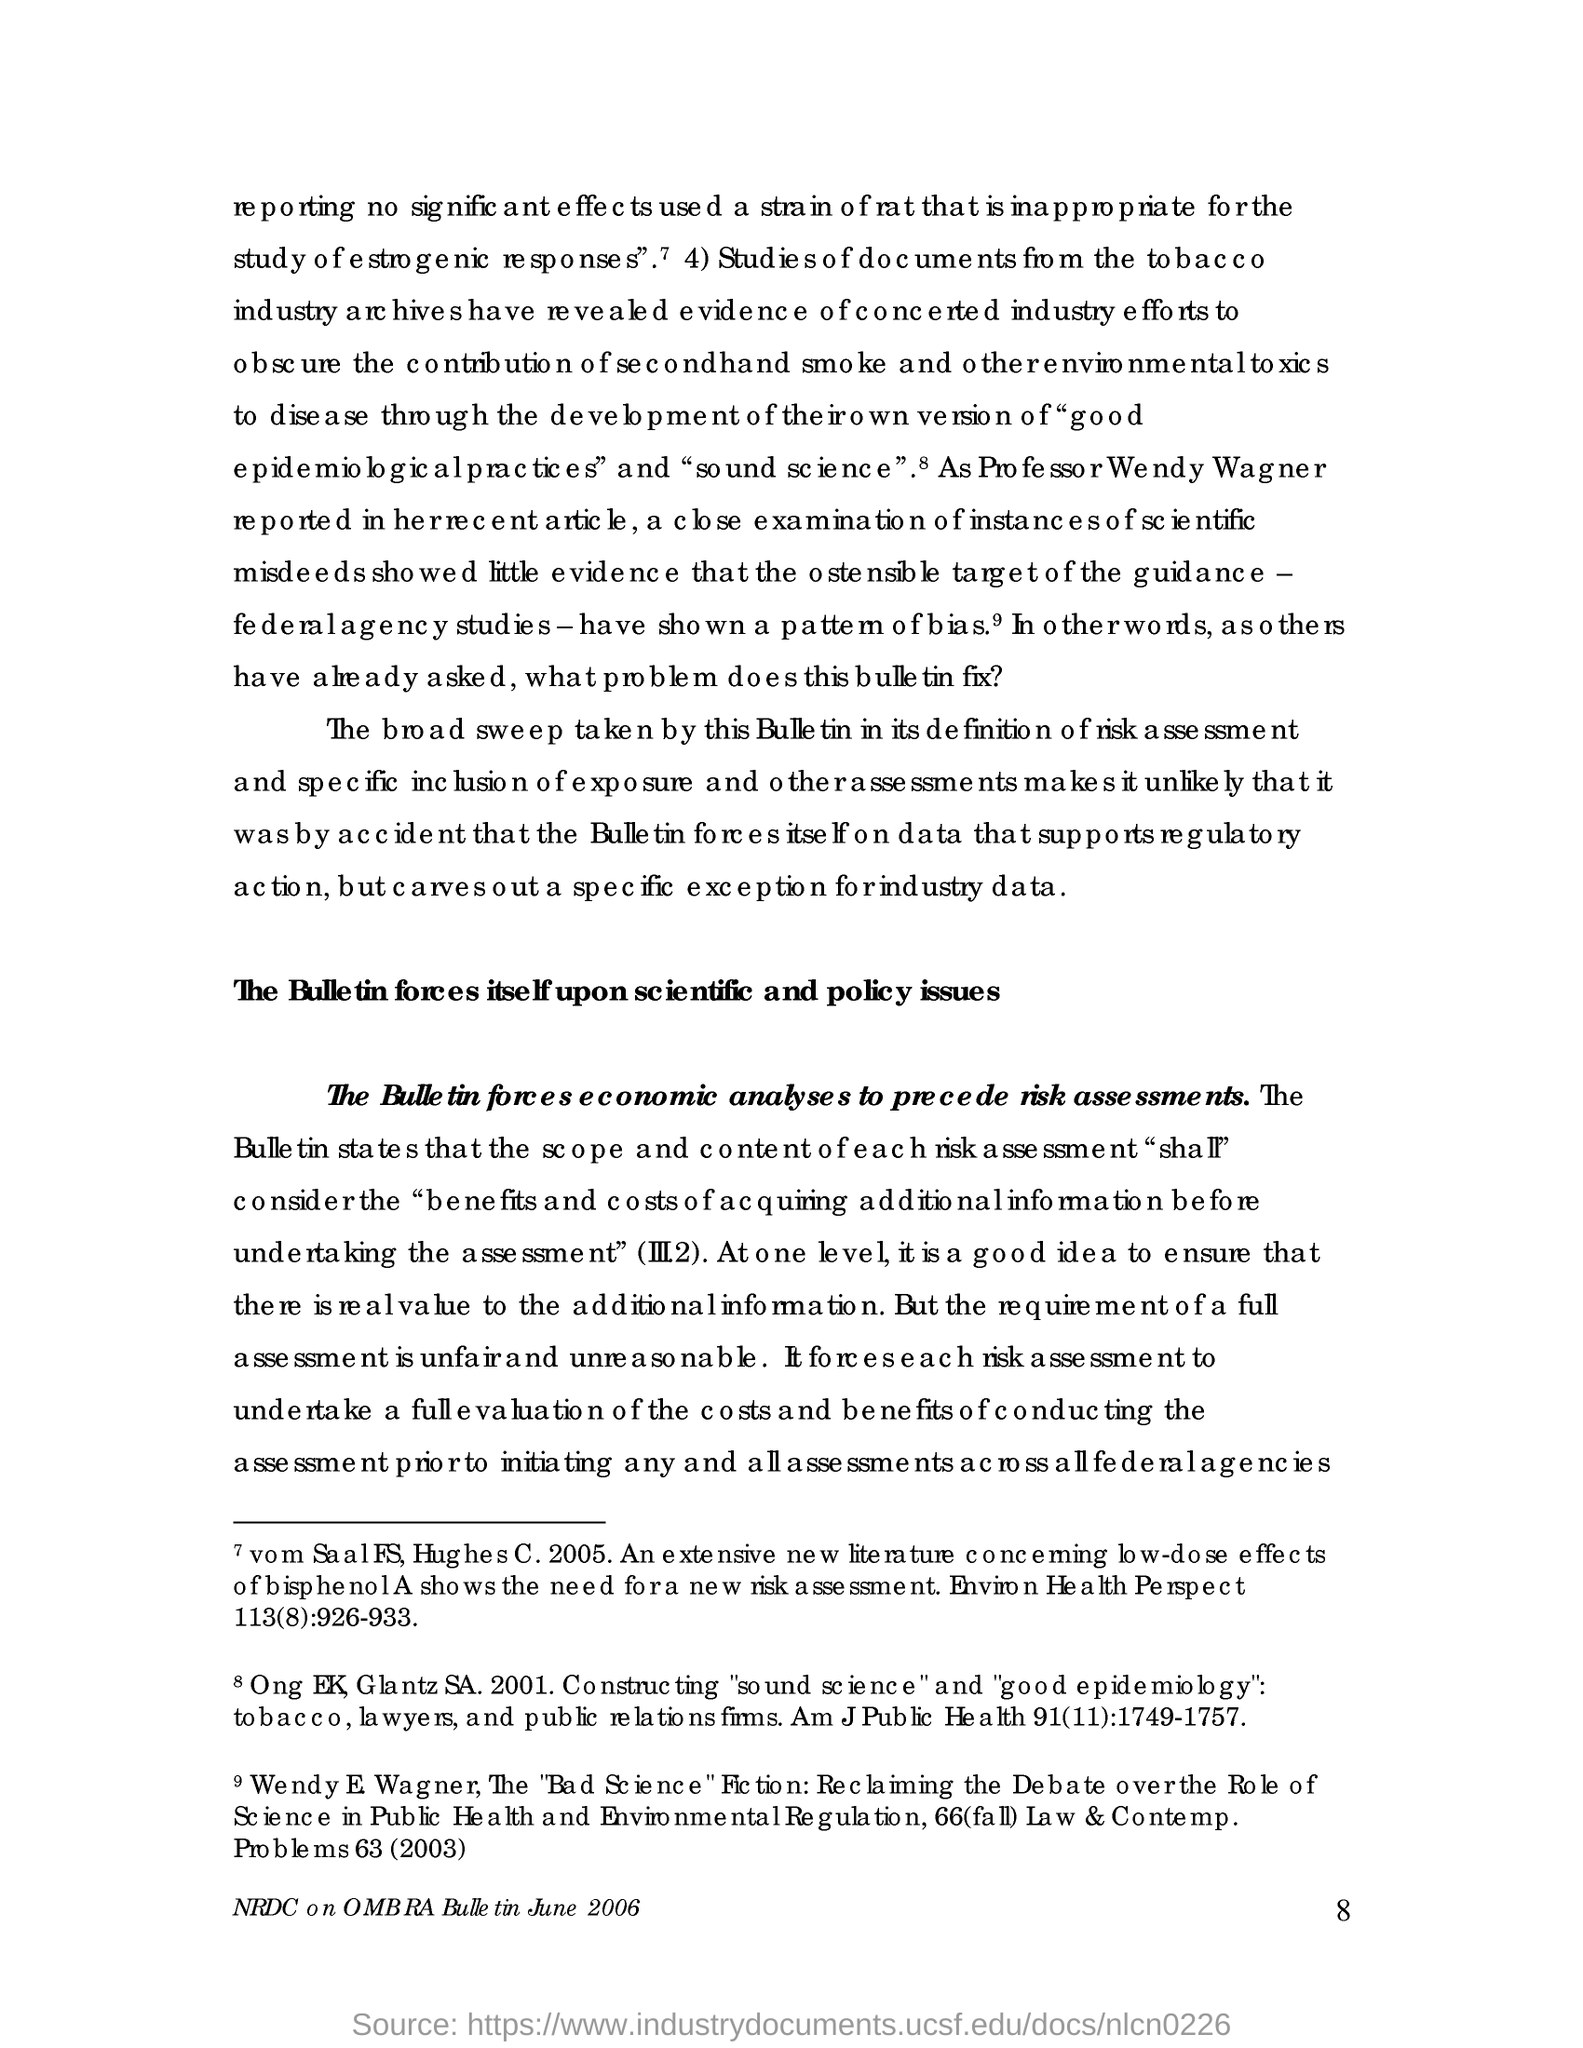What is the page no mentioned in this document?
Keep it short and to the point. 8. 